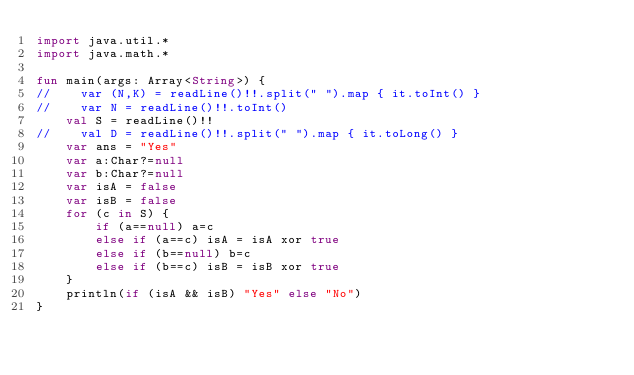<code> <loc_0><loc_0><loc_500><loc_500><_Kotlin_>import java.util.*
import java.math.*

fun main(args: Array<String>) {
//    var (N,K) = readLine()!!.split(" ").map { it.toInt() }
//    var N = readLine()!!.toInt()
    val S = readLine()!!
//    val D = readLine()!!.split(" ").map { it.toLong() }
    var ans = "Yes"
    var a:Char?=null
    var b:Char?=null
    var isA = false
    var isB = false
    for (c in S) {
        if (a==null) a=c
        else if (a==c) isA = isA xor true
        else if (b==null) b=c
        else if (b==c) isB = isB xor true
    }
    println(if (isA && isB) "Yes" else "No")
}
</code> 